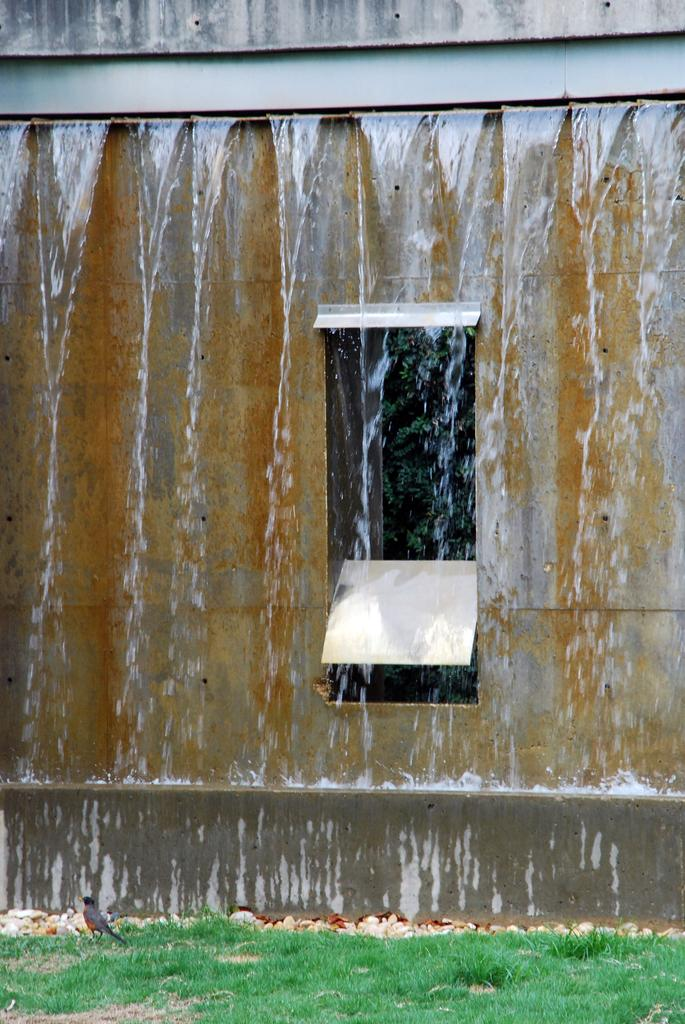What is the main structure visible in the image? There is a wall with a window in the image. What is happening with the water in the image? Water is falling from the top in the image. What type of vegetation can be seen in the image? There is grass visible in the image. What type of animal is present in the image? There is a bird in the image. What can be seen through the window in the image? Trees are visible through the window in the image. What type of roof can be seen on the bird in the image? There is no roof present on the bird in the image; birds do not have roofs. 